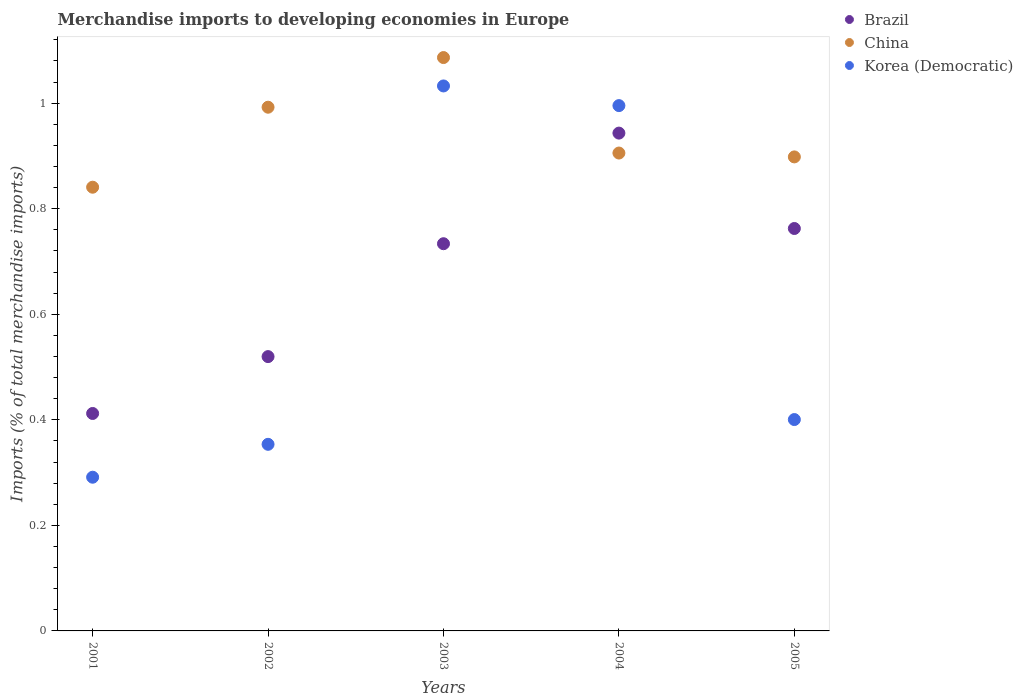How many different coloured dotlines are there?
Offer a terse response. 3. What is the percentage total merchandise imports in Korea (Democratic) in 2002?
Your answer should be compact. 0.35. Across all years, what is the maximum percentage total merchandise imports in Korea (Democratic)?
Keep it short and to the point. 1.03. Across all years, what is the minimum percentage total merchandise imports in China?
Keep it short and to the point. 0.84. In which year was the percentage total merchandise imports in China maximum?
Keep it short and to the point. 2003. What is the total percentage total merchandise imports in Korea (Democratic) in the graph?
Your answer should be very brief. 3.07. What is the difference between the percentage total merchandise imports in Brazil in 2001 and that in 2004?
Make the answer very short. -0.53. What is the difference between the percentage total merchandise imports in China in 2005 and the percentage total merchandise imports in Brazil in 2001?
Ensure brevity in your answer.  0.49. What is the average percentage total merchandise imports in Korea (Democratic) per year?
Offer a terse response. 0.61. In the year 2001, what is the difference between the percentage total merchandise imports in China and percentage total merchandise imports in Brazil?
Make the answer very short. 0.43. In how many years, is the percentage total merchandise imports in China greater than 0.56 %?
Your response must be concise. 5. What is the ratio of the percentage total merchandise imports in China in 2002 to that in 2005?
Offer a very short reply. 1.1. Is the percentage total merchandise imports in Brazil in 2002 less than that in 2004?
Your answer should be compact. Yes. What is the difference between the highest and the second highest percentage total merchandise imports in Korea (Democratic)?
Offer a very short reply. 0.04. What is the difference between the highest and the lowest percentage total merchandise imports in Korea (Democratic)?
Offer a very short reply. 0.74. In how many years, is the percentage total merchandise imports in Brazil greater than the average percentage total merchandise imports in Brazil taken over all years?
Provide a succinct answer. 3. Does the percentage total merchandise imports in China monotonically increase over the years?
Keep it short and to the point. No. Is the percentage total merchandise imports in Korea (Democratic) strictly less than the percentage total merchandise imports in Brazil over the years?
Offer a terse response. No. How many dotlines are there?
Provide a succinct answer. 3. What is the difference between two consecutive major ticks on the Y-axis?
Ensure brevity in your answer.  0.2. Does the graph contain grids?
Keep it short and to the point. No. What is the title of the graph?
Your answer should be very brief. Merchandise imports to developing economies in Europe. What is the label or title of the Y-axis?
Offer a very short reply. Imports (% of total merchandise imports). What is the Imports (% of total merchandise imports) in Brazil in 2001?
Keep it short and to the point. 0.41. What is the Imports (% of total merchandise imports) of China in 2001?
Offer a terse response. 0.84. What is the Imports (% of total merchandise imports) of Korea (Democratic) in 2001?
Make the answer very short. 0.29. What is the Imports (% of total merchandise imports) in Brazil in 2002?
Make the answer very short. 0.52. What is the Imports (% of total merchandise imports) of China in 2002?
Make the answer very short. 0.99. What is the Imports (% of total merchandise imports) of Korea (Democratic) in 2002?
Keep it short and to the point. 0.35. What is the Imports (% of total merchandise imports) in Brazil in 2003?
Give a very brief answer. 0.73. What is the Imports (% of total merchandise imports) in China in 2003?
Ensure brevity in your answer.  1.09. What is the Imports (% of total merchandise imports) of Korea (Democratic) in 2003?
Keep it short and to the point. 1.03. What is the Imports (% of total merchandise imports) of Brazil in 2004?
Give a very brief answer. 0.94. What is the Imports (% of total merchandise imports) in China in 2004?
Make the answer very short. 0.91. What is the Imports (% of total merchandise imports) in Korea (Democratic) in 2004?
Keep it short and to the point. 1. What is the Imports (% of total merchandise imports) in Brazil in 2005?
Make the answer very short. 0.76. What is the Imports (% of total merchandise imports) in China in 2005?
Your answer should be compact. 0.9. What is the Imports (% of total merchandise imports) of Korea (Democratic) in 2005?
Make the answer very short. 0.4. Across all years, what is the maximum Imports (% of total merchandise imports) of Brazil?
Ensure brevity in your answer.  0.94. Across all years, what is the maximum Imports (% of total merchandise imports) in China?
Your response must be concise. 1.09. Across all years, what is the maximum Imports (% of total merchandise imports) of Korea (Democratic)?
Offer a terse response. 1.03. Across all years, what is the minimum Imports (% of total merchandise imports) of Brazil?
Make the answer very short. 0.41. Across all years, what is the minimum Imports (% of total merchandise imports) of China?
Provide a short and direct response. 0.84. Across all years, what is the minimum Imports (% of total merchandise imports) of Korea (Democratic)?
Provide a short and direct response. 0.29. What is the total Imports (% of total merchandise imports) of Brazil in the graph?
Your answer should be very brief. 3.37. What is the total Imports (% of total merchandise imports) in China in the graph?
Your answer should be compact. 4.72. What is the total Imports (% of total merchandise imports) of Korea (Democratic) in the graph?
Ensure brevity in your answer.  3.07. What is the difference between the Imports (% of total merchandise imports) of Brazil in 2001 and that in 2002?
Your answer should be very brief. -0.11. What is the difference between the Imports (% of total merchandise imports) in China in 2001 and that in 2002?
Give a very brief answer. -0.15. What is the difference between the Imports (% of total merchandise imports) in Korea (Democratic) in 2001 and that in 2002?
Provide a succinct answer. -0.06. What is the difference between the Imports (% of total merchandise imports) of Brazil in 2001 and that in 2003?
Provide a succinct answer. -0.32. What is the difference between the Imports (% of total merchandise imports) of China in 2001 and that in 2003?
Give a very brief answer. -0.25. What is the difference between the Imports (% of total merchandise imports) in Korea (Democratic) in 2001 and that in 2003?
Make the answer very short. -0.74. What is the difference between the Imports (% of total merchandise imports) in Brazil in 2001 and that in 2004?
Provide a succinct answer. -0.53. What is the difference between the Imports (% of total merchandise imports) in China in 2001 and that in 2004?
Your answer should be compact. -0.06. What is the difference between the Imports (% of total merchandise imports) of Korea (Democratic) in 2001 and that in 2004?
Give a very brief answer. -0.7. What is the difference between the Imports (% of total merchandise imports) in Brazil in 2001 and that in 2005?
Provide a short and direct response. -0.35. What is the difference between the Imports (% of total merchandise imports) in China in 2001 and that in 2005?
Give a very brief answer. -0.06. What is the difference between the Imports (% of total merchandise imports) in Korea (Democratic) in 2001 and that in 2005?
Provide a succinct answer. -0.11. What is the difference between the Imports (% of total merchandise imports) in Brazil in 2002 and that in 2003?
Give a very brief answer. -0.21. What is the difference between the Imports (% of total merchandise imports) of China in 2002 and that in 2003?
Your response must be concise. -0.09. What is the difference between the Imports (% of total merchandise imports) of Korea (Democratic) in 2002 and that in 2003?
Offer a terse response. -0.68. What is the difference between the Imports (% of total merchandise imports) of Brazil in 2002 and that in 2004?
Offer a terse response. -0.42. What is the difference between the Imports (% of total merchandise imports) of China in 2002 and that in 2004?
Your answer should be compact. 0.09. What is the difference between the Imports (% of total merchandise imports) of Korea (Democratic) in 2002 and that in 2004?
Ensure brevity in your answer.  -0.64. What is the difference between the Imports (% of total merchandise imports) of Brazil in 2002 and that in 2005?
Your response must be concise. -0.24. What is the difference between the Imports (% of total merchandise imports) in China in 2002 and that in 2005?
Give a very brief answer. 0.09. What is the difference between the Imports (% of total merchandise imports) of Korea (Democratic) in 2002 and that in 2005?
Provide a short and direct response. -0.05. What is the difference between the Imports (% of total merchandise imports) of Brazil in 2003 and that in 2004?
Provide a succinct answer. -0.21. What is the difference between the Imports (% of total merchandise imports) in China in 2003 and that in 2004?
Offer a terse response. 0.18. What is the difference between the Imports (% of total merchandise imports) of Korea (Democratic) in 2003 and that in 2004?
Keep it short and to the point. 0.04. What is the difference between the Imports (% of total merchandise imports) of Brazil in 2003 and that in 2005?
Ensure brevity in your answer.  -0.03. What is the difference between the Imports (% of total merchandise imports) of China in 2003 and that in 2005?
Your answer should be very brief. 0.19. What is the difference between the Imports (% of total merchandise imports) of Korea (Democratic) in 2003 and that in 2005?
Provide a succinct answer. 0.63. What is the difference between the Imports (% of total merchandise imports) in Brazil in 2004 and that in 2005?
Offer a very short reply. 0.18. What is the difference between the Imports (% of total merchandise imports) in China in 2004 and that in 2005?
Provide a succinct answer. 0.01. What is the difference between the Imports (% of total merchandise imports) of Korea (Democratic) in 2004 and that in 2005?
Your response must be concise. 0.59. What is the difference between the Imports (% of total merchandise imports) of Brazil in 2001 and the Imports (% of total merchandise imports) of China in 2002?
Offer a very short reply. -0.58. What is the difference between the Imports (% of total merchandise imports) of Brazil in 2001 and the Imports (% of total merchandise imports) of Korea (Democratic) in 2002?
Offer a terse response. 0.06. What is the difference between the Imports (% of total merchandise imports) in China in 2001 and the Imports (% of total merchandise imports) in Korea (Democratic) in 2002?
Make the answer very short. 0.49. What is the difference between the Imports (% of total merchandise imports) of Brazil in 2001 and the Imports (% of total merchandise imports) of China in 2003?
Your answer should be very brief. -0.67. What is the difference between the Imports (% of total merchandise imports) in Brazil in 2001 and the Imports (% of total merchandise imports) in Korea (Democratic) in 2003?
Your answer should be compact. -0.62. What is the difference between the Imports (% of total merchandise imports) in China in 2001 and the Imports (% of total merchandise imports) in Korea (Democratic) in 2003?
Give a very brief answer. -0.19. What is the difference between the Imports (% of total merchandise imports) of Brazil in 2001 and the Imports (% of total merchandise imports) of China in 2004?
Offer a terse response. -0.49. What is the difference between the Imports (% of total merchandise imports) of Brazil in 2001 and the Imports (% of total merchandise imports) of Korea (Democratic) in 2004?
Give a very brief answer. -0.58. What is the difference between the Imports (% of total merchandise imports) in China in 2001 and the Imports (% of total merchandise imports) in Korea (Democratic) in 2004?
Give a very brief answer. -0.15. What is the difference between the Imports (% of total merchandise imports) in Brazil in 2001 and the Imports (% of total merchandise imports) in China in 2005?
Provide a succinct answer. -0.49. What is the difference between the Imports (% of total merchandise imports) in Brazil in 2001 and the Imports (% of total merchandise imports) in Korea (Democratic) in 2005?
Give a very brief answer. 0.01. What is the difference between the Imports (% of total merchandise imports) of China in 2001 and the Imports (% of total merchandise imports) of Korea (Democratic) in 2005?
Make the answer very short. 0.44. What is the difference between the Imports (% of total merchandise imports) in Brazil in 2002 and the Imports (% of total merchandise imports) in China in 2003?
Your response must be concise. -0.57. What is the difference between the Imports (% of total merchandise imports) in Brazil in 2002 and the Imports (% of total merchandise imports) in Korea (Democratic) in 2003?
Offer a terse response. -0.51. What is the difference between the Imports (% of total merchandise imports) in China in 2002 and the Imports (% of total merchandise imports) in Korea (Democratic) in 2003?
Provide a succinct answer. -0.04. What is the difference between the Imports (% of total merchandise imports) in Brazil in 2002 and the Imports (% of total merchandise imports) in China in 2004?
Keep it short and to the point. -0.39. What is the difference between the Imports (% of total merchandise imports) in Brazil in 2002 and the Imports (% of total merchandise imports) in Korea (Democratic) in 2004?
Your response must be concise. -0.48. What is the difference between the Imports (% of total merchandise imports) in China in 2002 and the Imports (% of total merchandise imports) in Korea (Democratic) in 2004?
Your response must be concise. -0. What is the difference between the Imports (% of total merchandise imports) in Brazil in 2002 and the Imports (% of total merchandise imports) in China in 2005?
Your answer should be very brief. -0.38. What is the difference between the Imports (% of total merchandise imports) in Brazil in 2002 and the Imports (% of total merchandise imports) in Korea (Democratic) in 2005?
Provide a short and direct response. 0.12. What is the difference between the Imports (% of total merchandise imports) in China in 2002 and the Imports (% of total merchandise imports) in Korea (Democratic) in 2005?
Provide a short and direct response. 0.59. What is the difference between the Imports (% of total merchandise imports) of Brazil in 2003 and the Imports (% of total merchandise imports) of China in 2004?
Ensure brevity in your answer.  -0.17. What is the difference between the Imports (% of total merchandise imports) of Brazil in 2003 and the Imports (% of total merchandise imports) of Korea (Democratic) in 2004?
Make the answer very short. -0.26. What is the difference between the Imports (% of total merchandise imports) of China in 2003 and the Imports (% of total merchandise imports) of Korea (Democratic) in 2004?
Keep it short and to the point. 0.09. What is the difference between the Imports (% of total merchandise imports) of Brazil in 2003 and the Imports (% of total merchandise imports) of China in 2005?
Your answer should be very brief. -0.16. What is the difference between the Imports (% of total merchandise imports) of Brazil in 2003 and the Imports (% of total merchandise imports) of Korea (Democratic) in 2005?
Offer a very short reply. 0.33. What is the difference between the Imports (% of total merchandise imports) of China in 2003 and the Imports (% of total merchandise imports) of Korea (Democratic) in 2005?
Ensure brevity in your answer.  0.69. What is the difference between the Imports (% of total merchandise imports) in Brazil in 2004 and the Imports (% of total merchandise imports) in China in 2005?
Your response must be concise. 0.05. What is the difference between the Imports (% of total merchandise imports) of Brazil in 2004 and the Imports (% of total merchandise imports) of Korea (Democratic) in 2005?
Keep it short and to the point. 0.54. What is the difference between the Imports (% of total merchandise imports) in China in 2004 and the Imports (% of total merchandise imports) in Korea (Democratic) in 2005?
Offer a terse response. 0.51. What is the average Imports (% of total merchandise imports) of Brazil per year?
Give a very brief answer. 0.67. What is the average Imports (% of total merchandise imports) of China per year?
Offer a very short reply. 0.94. What is the average Imports (% of total merchandise imports) in Korea (Democratic) per year?
Offer a terse response. 0.61. In the year 2001, what is the difference between the Imports (% of total merchandise imports) of Brazil and Imports (% of total merchandise imports) of China?
Provide a succinct answer. -0.43. In the year 2001, what is the difference between the Imports (% of total merchandise imports) in Brazil and Imports (% of total merchandise imports) in Korea (Democratic)?
Keep it short and to the point. 0.12. In the year 2001, what is the difference between the Imports (% of total merchandise imports) of China and Imports (% of total merchandise imports) of Korea (Democratic)?
Keep it short and to the point. 0.55. In the year 2002, what is the difference between the Imports (% of total merchandise imports) of Brazil and Imports (% of total merchandise imports) of China?
Keep it short and to the point. -0.47. In the year 2002, what is the difference between the Imports (% of total merchandise imports) of Brazil and Imports (% of total merchandise imports) of Korea (Democratic)?
Your answer should be very brief. 0.17. In the year 2002, what is the difference between the Imports (% of total merchandise imports) of China and Imports (% of total merchandise imports) of Korea (Democratic)?
Ensure brevity in your answer.  0.64. In the year 2003, what is the difference between the Imports (% of total merchandise imports) of Brazil and Imports (% of total merchandise imports) of China?
Offer a terse response. -0.35. In the year 2003, what is the difference between the Imports (% of total merchandise imports) in Brazil and Imports (% of total merchandise imports) in Korea (Democratic)?
Make the answer very short. -0.3. In the year 2003, what is the difference between the Imports (% of total merchandise imports) in China and Imports (% of total merchandise imports) in Korea (Democratic)?
Give a very brief answer. 0.05. In the year 2004, what is the difference between the Imports (% of total merchandise imports) of Brazil and Imports (% of total merchandise imports) of China?
Your answer should be very brief. 0.04. In the year 2004, what is the difference between the Imports (% of total merchandise imports) in Brazil and Imports (% of total merchandise imports) in Korea (Democratic)?
Provide a short and direct response. -0.05. In the year 2004, what is the difference between the Imports (% of total merchandise imports) in China and Imports (% of total merchandise imports) in Korea (Democratic)?
Your response must be concise. -0.09. In the year 2005, what is the difference between the Imports (% of total merchandise imports) of Brazil and Imports (% of total merchandise imports) of China?
Provide a succinct answer. -0.14. In the year 2005, what is the difference between the Imports (% of total merchandise imports) of Brazil and Imports (% of total merchandise imports) of Korea (Democratic)?
Make the answer very short. 0.36. In the year 2005, what is the difference between the Imports (% of total merchandise imports) of China and Imports (% of total merchandise imports) of Korea (Democratic)?
Your answer should be very brief. 0.5. What is the ratio of the Imports (% of total merchandise imports) in Brazil in 2001 to that in 2002?
Your answer should be compact. 0.79. What is the ratio of the Imports (% of total merchandise imports) of China in 2001 to that in 2002?
Your response must be concise. 0.85. What is the ratio of the Imports (% of total merchandise imports) of Korea (Democratic) in 2001 to that in 2002?
Offer a very short reply. 0.82. What is the ratio of the Imports (% of total merchandise imports) of Brazil in 2001 to that in 2003?
Your answer should be compact. 0.56. What is the ratio of the Imports (% of total merchandise imports) of China in 2001 to that in 2003?
Offer a terse response. 0.77. What is the ratio of the Imports (% of total merchandise imports) of Korea (Democratic) in 2001 to that in 2003?
Give a very brief answer. 0.28. What is the ratio of the Imports (% of total merchandise imports) in Brazil in 2001 to that in 2004?
Your answer should be compact. 0.44. What is the ratio of the Imports (% of total merchandise imports) of China in 2001 to that in 2004?
Keep it short and to the point. 0.93. What is the ratio of the Imports (% of total merchandise imports) in Korea (Democratic) in 2001 to that in 2004?
Ensure brevity in your answer.  0.29. What is the ratio of the Imports (% of total merchandise imports) of Brazil in 2001 to that in 2005?
Offer a terse response. 0.54. What is the ratio of the Imports (% of total merchandise imports) of China in 2001 to that in 2005?
Your response must be concise. 0.94. What is the ratio of the Imports (% of total merchandise imports) in Korea (Democratic) in 2001 to that in 2005?
Your answer should be compact. 0.73. What is the ratio of the Imports (% of total merchandise imports) of Brazil in 2002 to that in 2003?
Provide a short and direct response. 0.71. What is the ratio of the Imports (% of total merchandise imports) in China in 2002 to that in 2003?
Your answer should be compact. 0.91. What is the ratio of the Imports (% of total merchandise imports) of Korea (Democratic) in 2002 to that in 2003?
Provide a short and direct response. 0.34. What is the ratio of the Imports (% of total merchandise imports) in Brazil in 2002 to that in 2004?
Offer a very short reply. 0.55. What is the ratio of the Imports (% of total merchandise imports) in China in 2002 to that in 2004?
Your response must be concise. 1.1. What is the ratio of the Imports (% of total merchandise imports) in Korea (Democratic) in 2002 to that in 2004?
Your answer should be compact. 0.36. What is the ratio of the Imports (% of total merchandise imports) in Brazil in 2002 to that in 2005?
Your answer should be compact. 0.68. What is the ratio of the Imports (% of total merchandise imports) of China in 2002 to that in 2005?
Give a very brief answer. 1.1. What is the ratio of the Imports (% of total merchandise imports) in Korea (Democratic) in 2002 to that in 2005?
Keep it short and to the point. 0.88. What is the ratio of the Imports (% of total merchandise imports) in China in 2003 to that in 2004?
Make the answer very short. 1.2. What is the ratio of the Imports (% of total merchandise imports) of Korea (Democratic) in 2003 to that in 2004?
Ensure brevity in your answer.  1.04. What is the ratio of the Imports (% of total merchandise imports) in Brazil in 2003 to that in 2005?
Your answer should be very brief. 0.96. What is the ratio of the Imports (% of total merchandise imports) in China in 2003 to that in 2005?
Keep it short and to the point. 1.21. What is the ratio of the Imports (% of total merchandise imports) in Korea (Democratic) in 2003 to that in 2005?
Provide a succinct answer. 2.58. What is the ratio of the Imports (% of total merchandise imports) in Brazil in 2004 to that in 2005?
Provide a short and direct response. 1.24. What is the ratio of the Imports (% of total merchandise imports) in China in 2004 to that in 2005?
Make the answer very short. 1.01. What is the ratio of the Imports (% of total merchandise imports) in Korea (Democratic) in 2004 to that in 2005?
Your response must be concise. 2.49. What is the difference between the highest and the second highest Imports (% of total merchandise imports) of Brazil?
Keep it short and to the point. 0.18. What is the difference between the highest and the second highest Imports (% of total merchandise imports) in China?
Give a very brief answer. 0.09. What is the difference between the highest and the second highest Imports (% of total merchandise imports) in Korea (Democratic)?
Provide a short and direct response. 0.04. What is the difference between the highest and the lowest Imports (% of total merchandise imports) in Brazil?
Make the answer very short. 0.53. What is the difference between the highest and the lowest Imports (% of total merchandise imports) in China?
Offer a very short reply. 0.25. What is the difference between the highest and the lowest Imports (% of total merchandise imports) of Korea (Democratic)?
Provide a short and direct response. 0.74. 